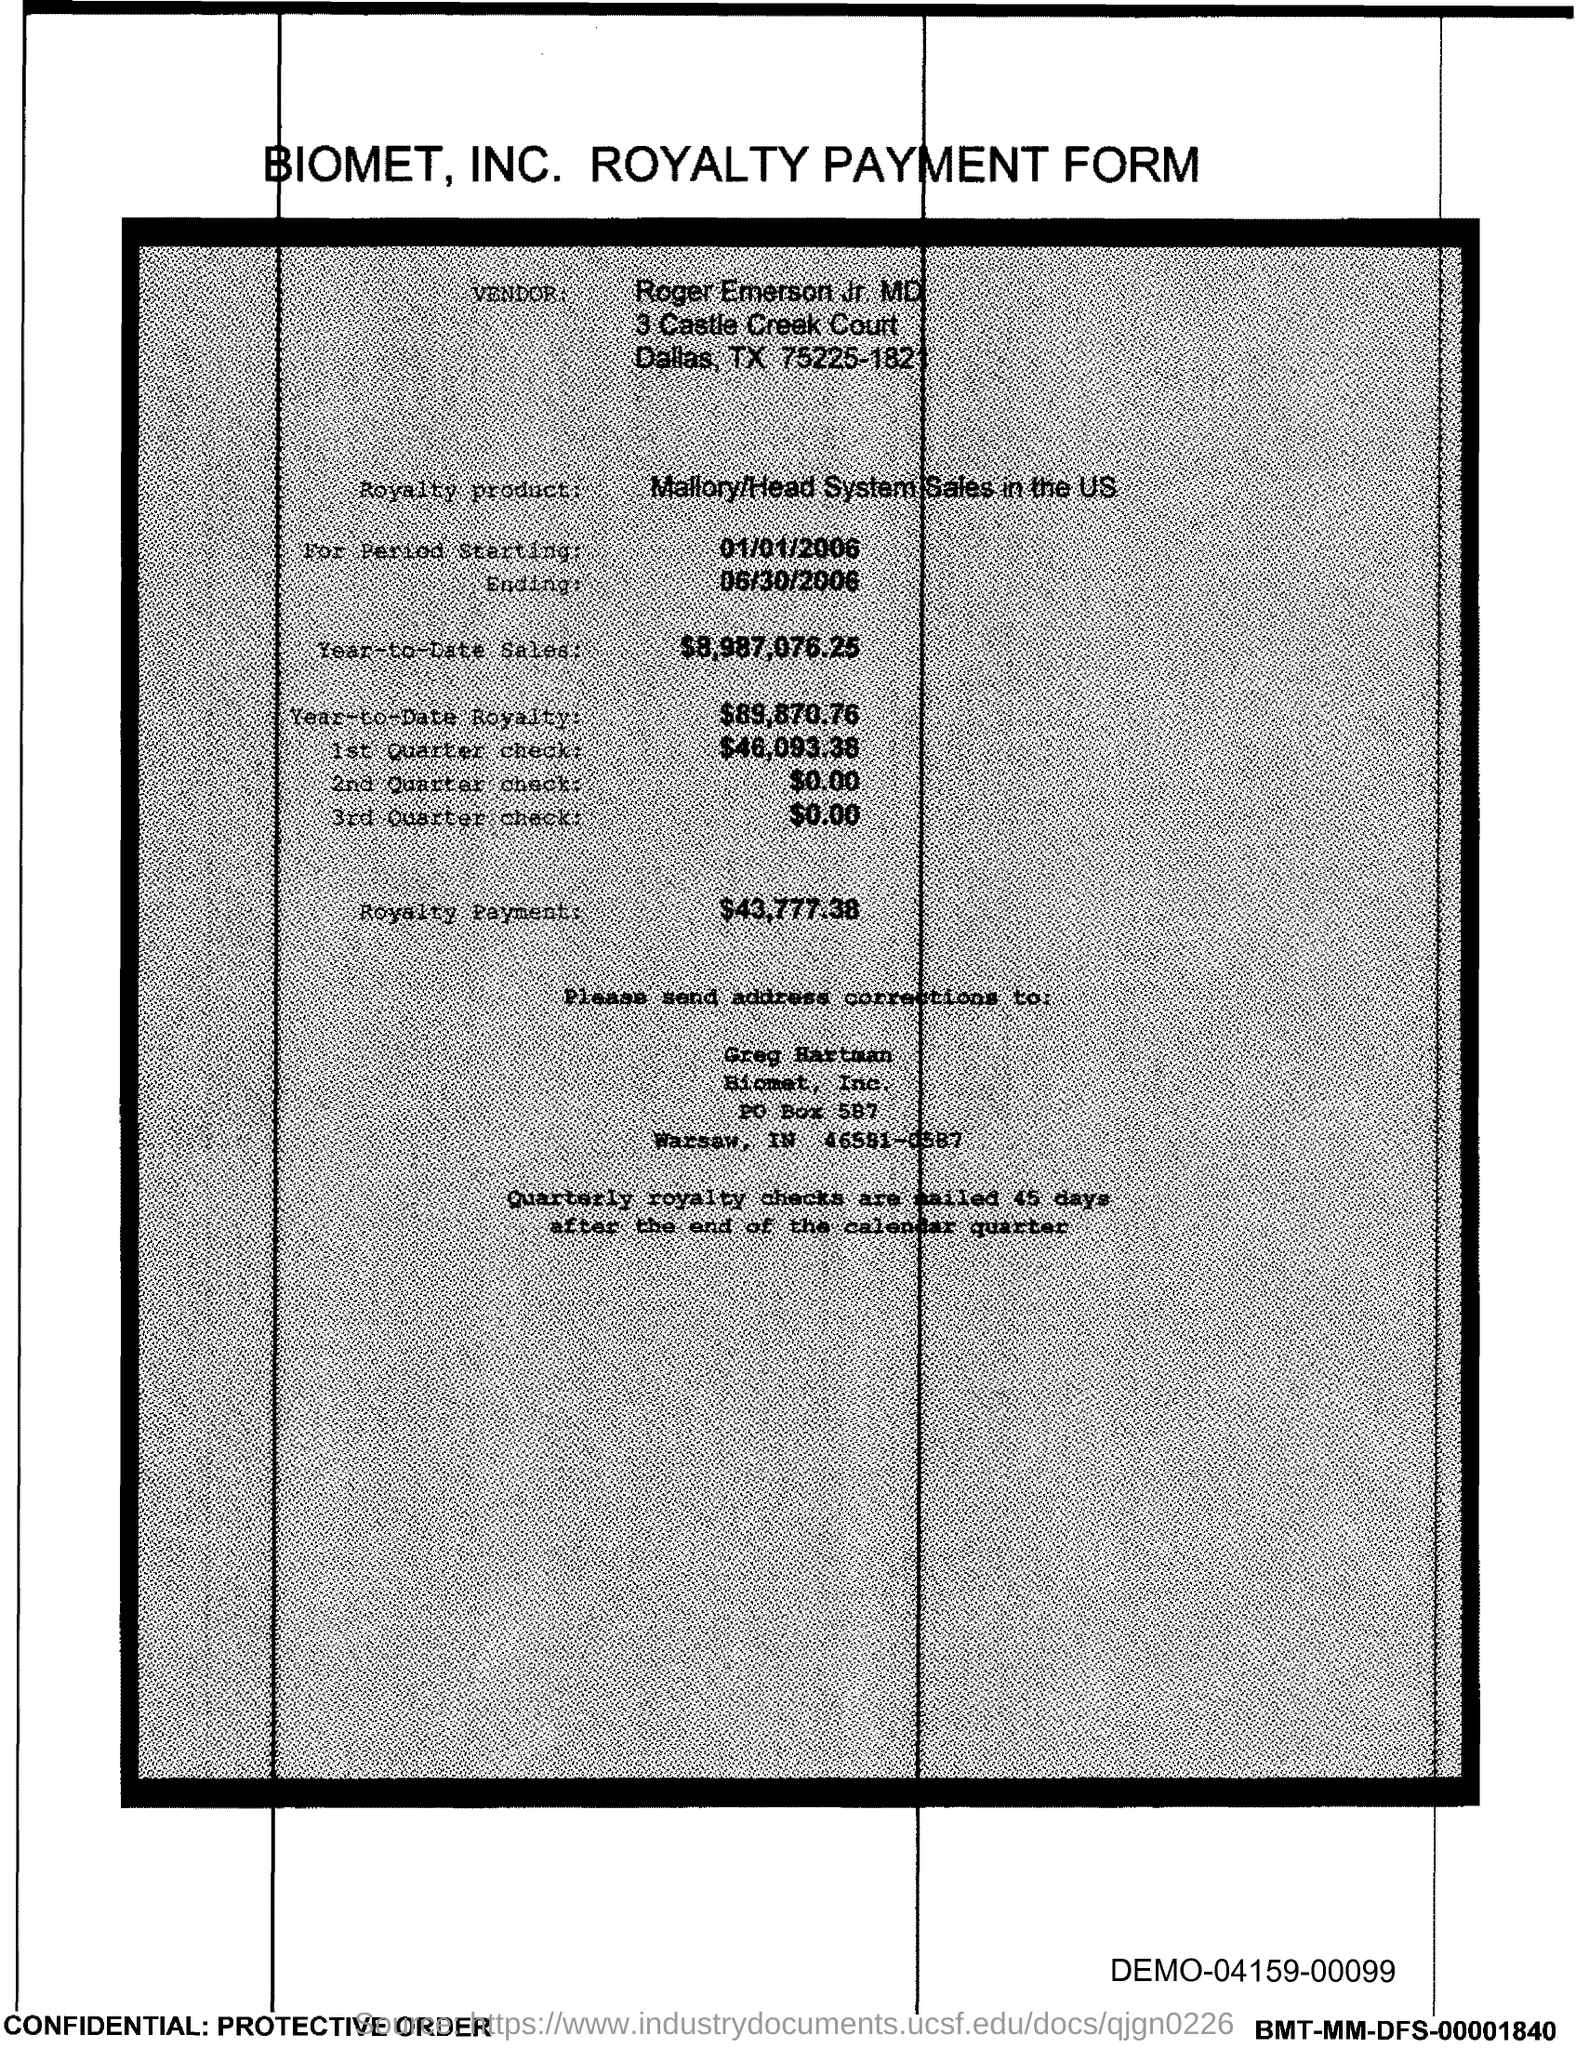What is the vendor name given in the form?
Ensure brevity in your answer.  Roger Emerson Jr, MD. What is the royalty product given in the form?
Provide a succinct answer. Mallory/Head System Sales in the US. What is the start date of the royalty period?
Make the answer very short. 01/01/2006. What is the Year-to-Date Sales of the royalty product?
Your response must be concise. $8,987,076.25. What is the amount of 3rd Quarter check given in the form?
Give a very brief answer. $0.00. What is the amount of 1st quarter check mentioned in the form?
Your answer should be compact. $46,093.38. What is the Year-to-Date royalty of the product?
Offer a terse response. $89,870.76. Who is responsible to do the address corrections?
Offer a terse response. Greg Hartman. What is the end date of the royalty period?
Offer a very short reply. 06/30/2006. 